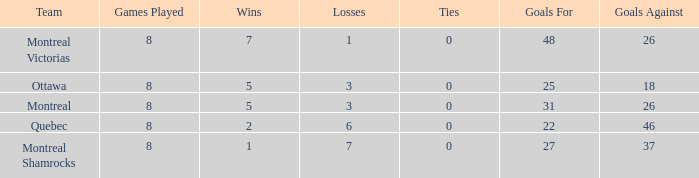For teams with fewer than 5 wins, goals against over 37, and fewer than 8 games played, what is the average number of ties? None. I'm looking to parse the entire table for insights. Could you assist me with that? {'header': ['Team', 'Games Played', 'Wins', 'Losses', 'Ties', 'Goals For', 'Goals Against'], 'rows': [['Montreal Victorias', '8', '7', '1', '0', '48', '26'], ['Ottawa', '8', '5', '3', '0', '25', '18'], ['Montreal', '8', '5', '3', '0', '31', '26'], ['Quebec', '8', '2', '6', '0', '22', '46'], ['Montreal Shamrocks', '8', '1', '7', '0', '27', '37']]} 